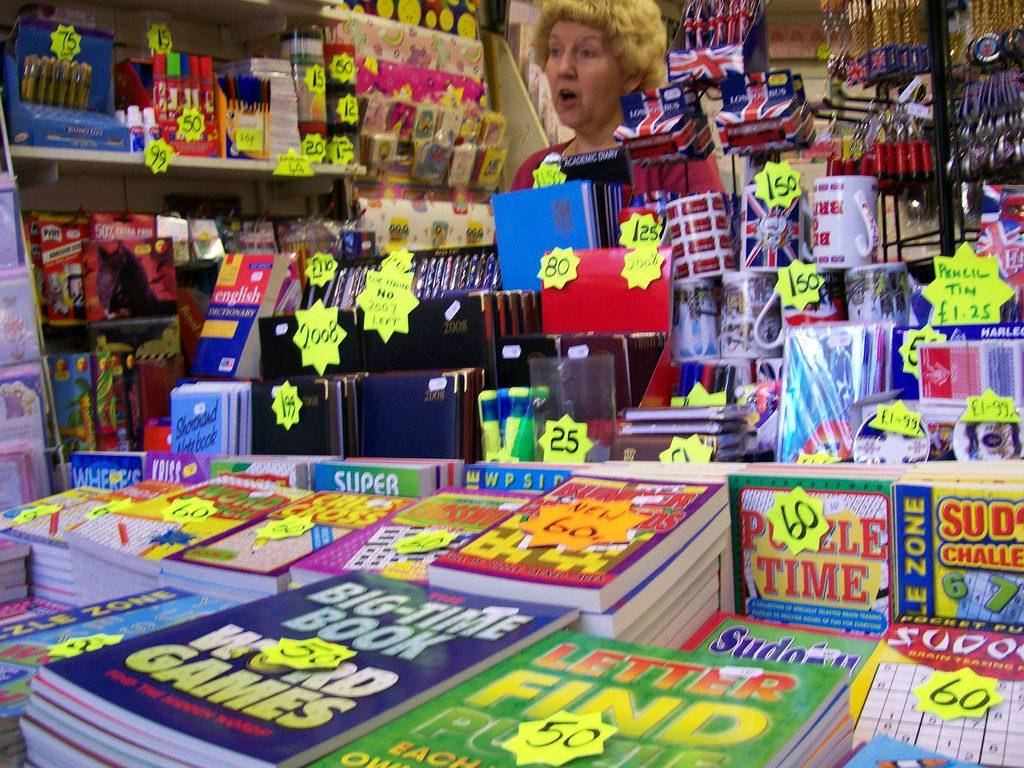<image>
Render a clear and concise summary of the photo. Woman working behind a counter selling books including one for Puzzle Time. 